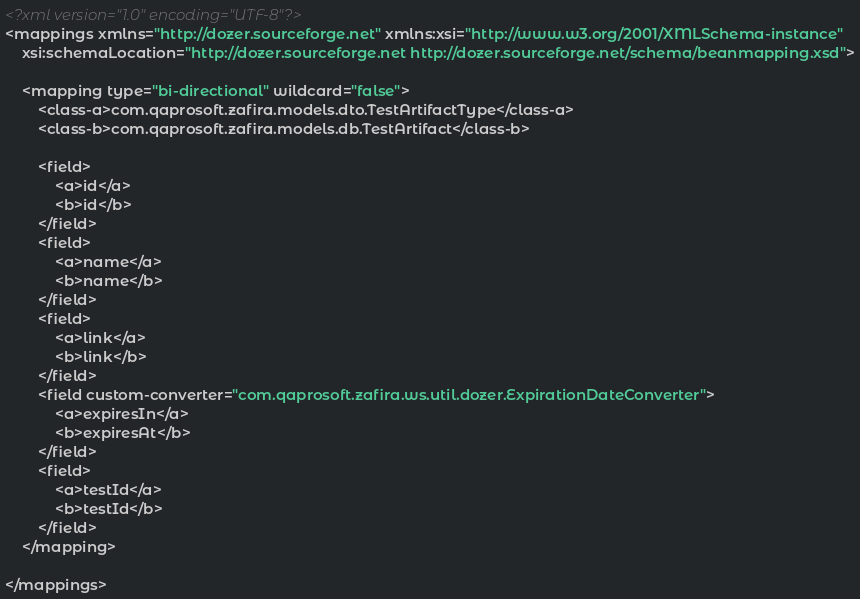<code> <loc_0><loc_0><loc_500><loc_500><_XML_><?xml version="1.0" encoding="UTF-8"?>
<mappings xmlns="http://dozer.sourceforge.net" xmlns:xsi="http://www.w3.org/2001/XMLSchema-instance"
	xsi:schemaLocation="http://dozer.sourceforge.net http://dozer.sourceforge.net/schema/beanmapping.xsd">

	<mapping type="bi-directional" wildcard="false">
		<class-a>com.qaprosoft.zafira.models.dto.TestArtifactType</class-a>
		<class-b>com.qaprosoft.zafira.models.db.TestArtifact</class-b>

		<field>
			<a>id</a>
			<b>id</b>
		</field>
		<field>
			<a>name</a>
			<b>name</b>
		</field>
		<field>
			<a>link</a>
			<b>link</b>
		</field>
		<field custom-converter="com.qaprosoft.zafira.ws.util.dozer.ExpirationDateConverter">
			<a>expiresIn</a>
			<b>expiresAt</b>
		</field>
		<field>
			<a>testId</a>
			<b>testId</b>
		</field>
	</mapping>
	
</mappings>
</code> 